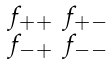Convert formula to latex. <formula><loc_0><loc_0><loc_500><loc_500>\begin{smallmatrix} f _ { + + } & f _ { + - } \\ f _ { - + } & f _ { - - } \end{smallmatrix}</formula> 